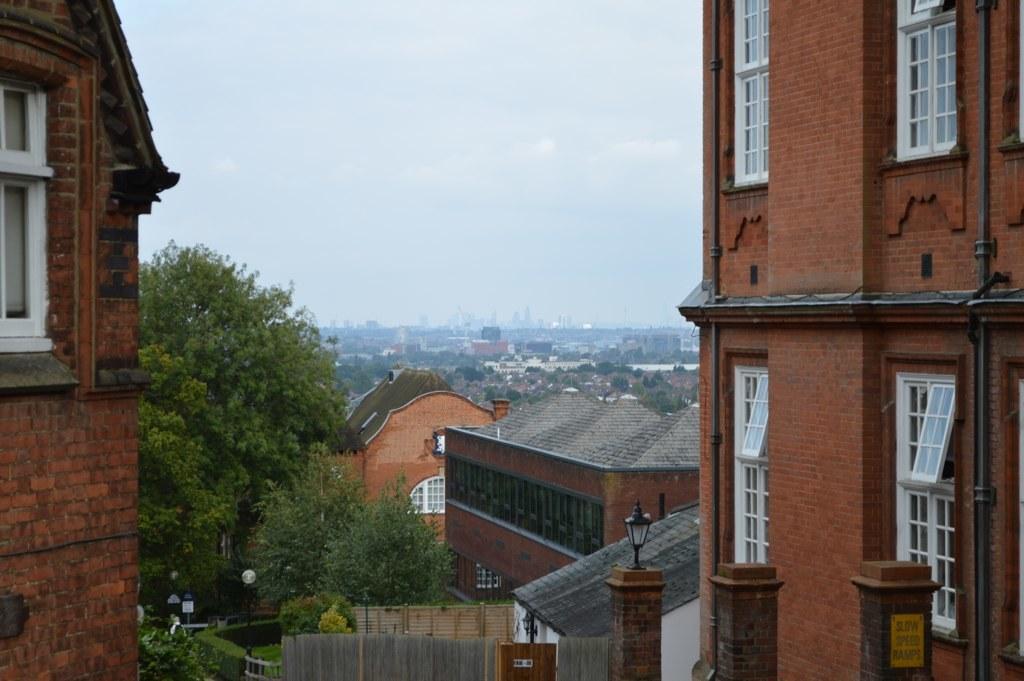Could you give a brief overview of what you see in this image? In this image we can see buildings, trees, poles, street lights, bushes, pillars, windows and sky. 